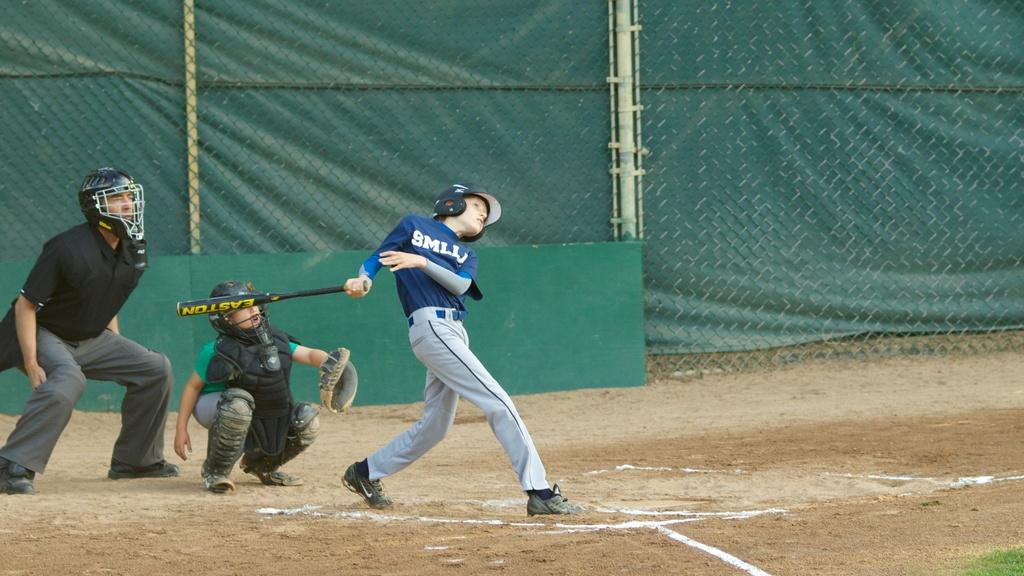What team is the boy playing for?
Your answer should be very brief. Unanswerable. What company name is printed on the baseball bat?
Your answer should be compact. Easton. 